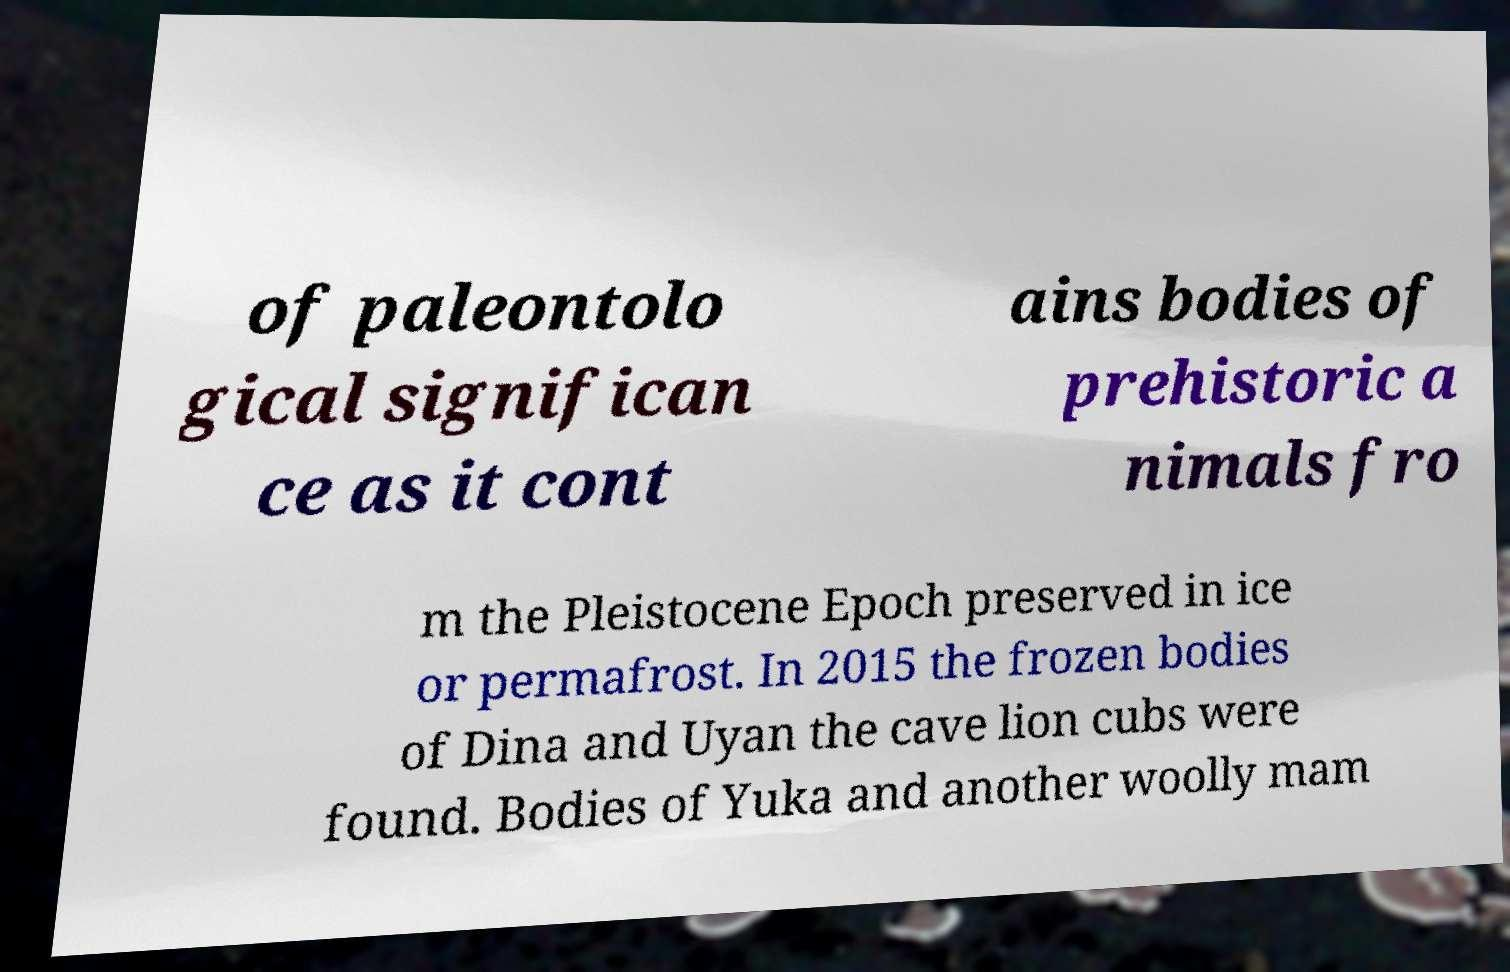Could you assist in decoding the text presented in this image and type it out clearly? of paleontolo gical significan ce as it cont ains bodies of prehistoric a nimals fro m the Pleistocene Epoch preserved in ice or permafrost. In 2015 the frozen bodies of Dina and Uyan the cave lion cubs were found. Bodies of Yuka and another woolly mam 